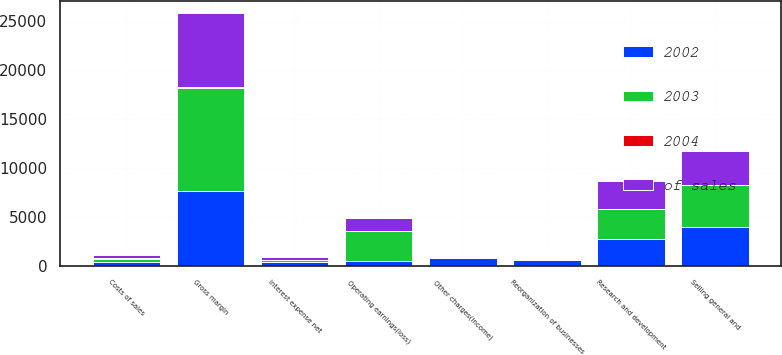Convert chart. <chart><loc_0><loc_0><loc_500><loc_500><stacked_bar_chart><ecel><fcel>Costs of sales<fcel>Gross margin<fcel>Selling general and<fcel>Research and development<fcel>Reorganization of businesses<fcel>Other charges(income)<fcel>Operating earnings(loss)<fcel>Interest expense net<nl><fcel>2003<fcel>355<fcel>10497<fcel>4209<fcel>3060<fcel>15<fcel>111<fcel>3132<fcel>199<nl><fcel>2004<fcel>66.5<fcel>33.5<fcel>13.4<fcel>9.8<fcel>0.1<fcel>0.4<fcel>10<fcel>0.6<nl><fcel>of sales<fcel>355<fcel>7567<fcel>3529<fcel>2799<fcel>23<fcel>57<fcel>1273<fcel>294<nl><fcel>2002<fcel>355<fcel>7681<fcel>3991<fcel>2774<fcel>605<fcel>754<fcel>443<fcel>355<nl></chart> 